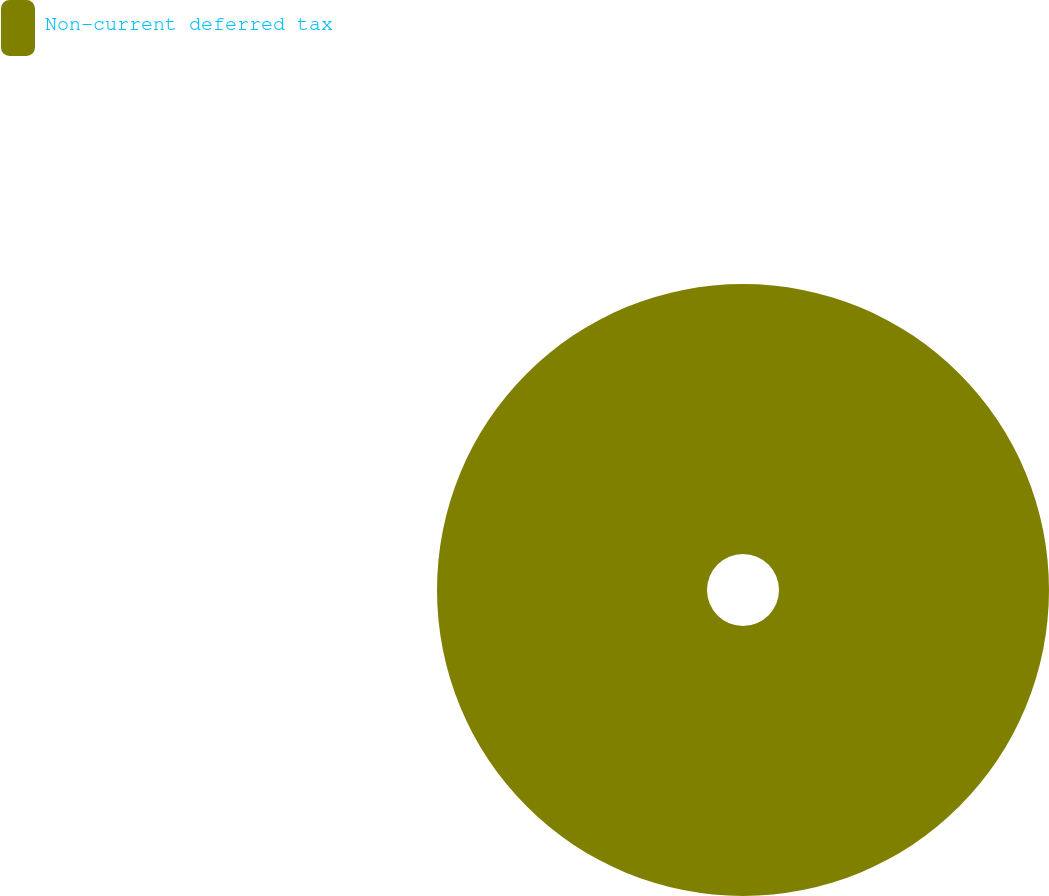Convert chart to OTSL. <chart><loc_0><loc_0><loc_500><loc_500><pie_chart><fcel>Non-current deferred tax<nl><fcel>100.0%<nl></chart> 